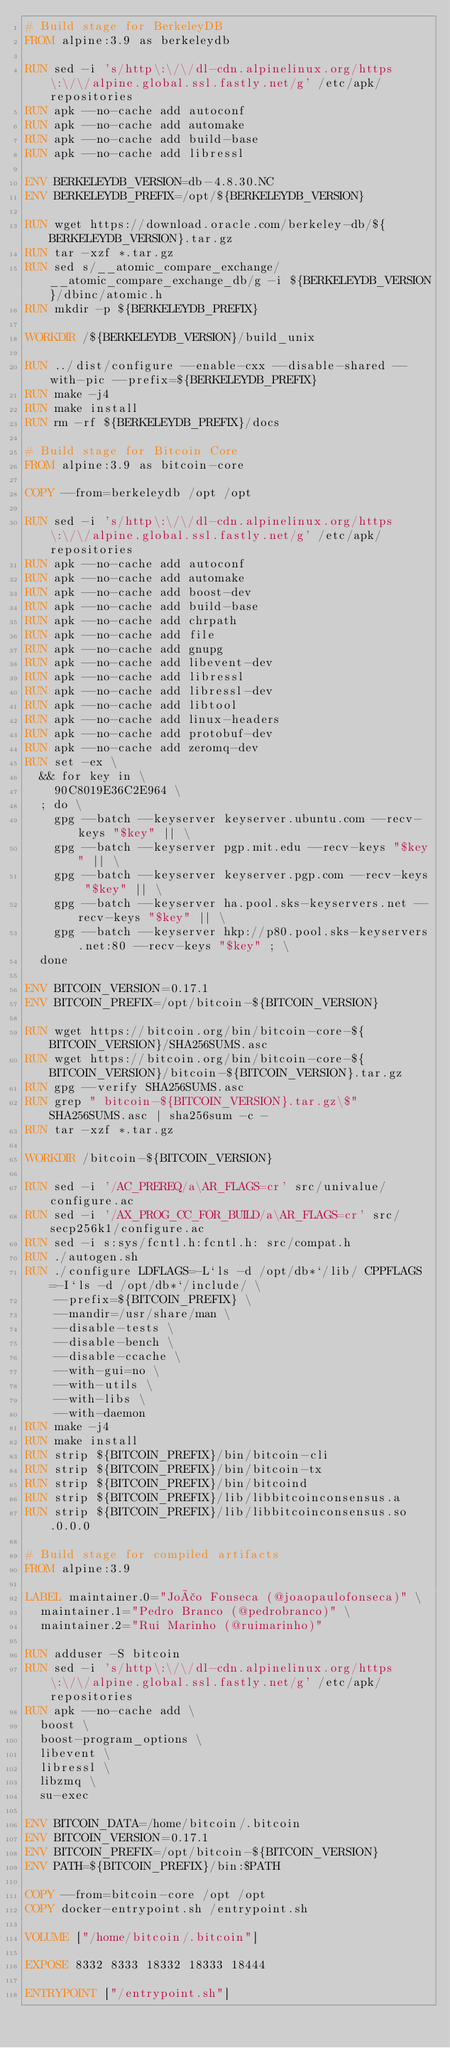<code> <loc_0><loc_0><loc_500><loc_500><_Dockerfile_># Build stage for BerkeleyDB
FROM alpine:3.9 as berkeleydb

RUN sed -i 's/http\:\/\/dl-cdn.alpinelinux.org/https\:\/\/alpine.global.ssl.fastly.net/g' /etc/apk/repositories
RUN apk --no-cache add autoconf
RUN apk --no-cache add automake
RUN apk --no-cache add build-base
RUN apk --no-cache add libressl

ENV BERKELEYDB_VERSION=db-4.8.30.NC
ENV BERKELEYDB_PREFIX=/opt/${BERKELEYDB_VERSION}

RUN wget https://download.oracle.com/berkeley-db/${BERKELEYDB_VERSION}.tar.gz
RUN tar -xzf *.tar.gz
RUN sed s/__atomic_compare_exchange/__atomic_compare_exchange_db/g -i ${BERKELEYDB_VERSION}/dbinc/atomic.h
RUN mkdir -p ${BERKELEYDB_PREFIX}

WORKDIR /${BERKELEYDB_VERSION}/build_unix

RUN ../dist/configure --enable-cxx --disable-shared --with-pic --prefix=${BERKELEYDB_PREFIX}
RUN make -j4
RUN make install
RUN rm -rf ${BERKELEYDB_PREFIX}/docs

# Build stage for Bitcoin Core
FROM alpine:3.9 as bitcoin-core

COPY --from=berkeleydb /opt /opt

RUN sed -i 's/http\:\/\/dl-cdn.alpinelinux.org/https\:\/\/alpine.global.ssl.fastly.net/g' /etc/apk/repositories
RUN apk --no-cache add autoconf
RUN apk --no-cache add automake
RUN apk --no-cache add boost-dev
RUN apk --no-cache add build-base
RUN apk --no-cache add chrpath
RUN apk --no-cache add file
RUN apk --no-cache add gnupg
RUN apk --no-cache add libevent-dev
RUN apk --no-cache add libressl
RUN apk --no-cache add libressl-dev
RUN apk --no-cache add libtool
RUN apk --no-cache add linux-headers
RUN apk --no-cache add protobuf-dev
RUN apk --no-cache add zeromq-dev
RUN set -ex \
  && for key in \
    90C8019E36C2E964 \
  ; do \
    gpg --batch --keyserver keyserver.ubuntu.com --recv-keys "$key" || \
    gpg --batch --keyserver pgp.mit.edu --recv-keys "$key" || \
    gpg --batch --keyserver keyserver.pgp.com --recv-keys "$key" || \
    gpg --batch --keyserver ha.pool.sks-keyservers.net --recv-keys "$key" || \
    gpg --batch --keyserver hkp://p80.pool.sks-keyservers.net:80 --recv-keys "$key" ; \
  done

ENV BITCOIN_VERSION=0.17.1
ENV BITCOIN_PREFIX=/opt/bitcoin-${BITCOIN_VERSION}

RUN wget https://bitcoin.org/bin/bitcoin-core-${BITCOIN_VERSION}/SHA256SUMS.asc
RUN wget https://bitcoin.org/bin/bitcoin-core-${BITCOIN_VERSION}/bitcoin-${BITCOIN_VERSION}.tar.gz
RUN gpg --verify SHA256SUMS.asc
RUN grep " bitcoin-${BITCOIN_VERSION}.tar.gz\$" SHA256SUMS.asc | sha256sum -c -
RUN tar -xzf *.tar.gz

WORKDIR /bitcoin-${BITCOIN_VERSION}

RUN sed -i '/AC_PREREQ/a\AR_FLAGS=cr' src/univalue/configure.ac
RUN sed -i '/AX_PROG_CC_FOR_BUILD/a\AR_FLAGS=cr' src/secp256k1/configure.ac
RUN sed -i s:sys/fcntl.h:fcntl.h: src/compat.h
RUN ./autogen.sh
RUN ./configure LDFLAGS=-L`ls -d /opt/db*`/lib/ CPPFLAGS=-I`ls -d /opt/db*`/include/ \
    --prefix=${BITCOIN_PREFIX} \
    --mandir=/usr/share/man \
    --disable-tests \
    --disable-bench \
    --disable-ccache \
    --with-gui=no \
    --with-utils \
    --with-libs \
    --with-daemon
RUN make -j4
RUN make install
RUN strip ${BITCOIN_PREFIX}/bin/bitcoin-cli
RUN strip ${BITCOIN_PREFIX}/bin/bitcoin-tx
RUN strip ${BITCOIN_PREFIX}/bin/bitcoind
RUN strip ${BITCOIN_PREFIX}/lib/libbitcoinconsensus.a
RUN strip ${BITCOIN_PREFIX}/lib/libbitcoinconsensus.so.0.0.0

# Build stage for compiled artifacts
FROM alpine:3.9

LABEL maintainer.0="João Fonseca (@joaopaulofonseca)" \
  maintainer.1="Pedro Branco (@pedrobranco)" \
  maintainer.2="Rui Marinho (@ruimarinho)"

RUN adduser -S bitcoin
RUN sed -i 's/http\:\/\/dl-cdn.alpinelinux.org/https\:\/\/alpine.global.ssl.fastly.net/g' /etc/apk/repositories
RUN apk --no-cache add \
  boost \
  boost-program_options \
  libevent \
  libressl \
  libzmq \
  su-exec

ENV BITCOIN_DATA=/home/bitcoin/.bitcoin
ENV BITCOIN_VERSION=0.17.1
ENV BITCOIN_PREFIX=/opt/bitcoin-${BITCOIN_VERSION}
ENV PATH=${BITCOIN_PREFIX}/bin:$PATH

COPY --from=bitcoin-core /opt /opt
COPY docker-entrypoint.sh /entrypoint.sh

VOLUME ["/home/bitcoin/.bitcoin"]

EXPOSE 8332 8333 18332 18333 18444

ENTRYPOINT ["/entrypoint.sh"]
</code> 